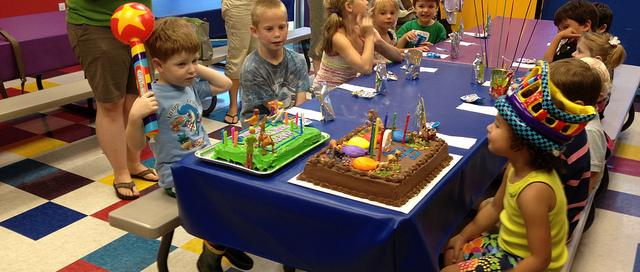Where is this party taking place? Please explain your reasoning. kid's restaurant. The setting in the background behind the kids is colorful and the cakes look professional which would be consistent with answer a. 